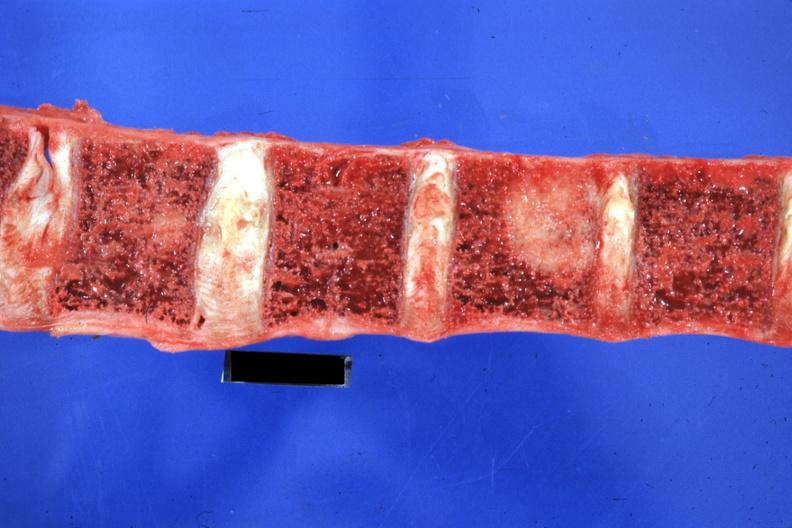what does this image show?
Answer the question using a single word or phrase. Easily seen large lesion primary in tail of pancreas 